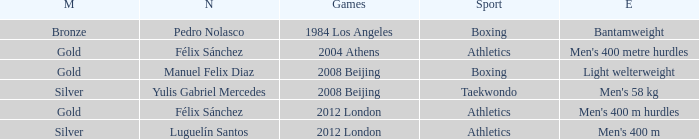Which Games had a Name of manuel felix diaz? 2008 Beijing. 